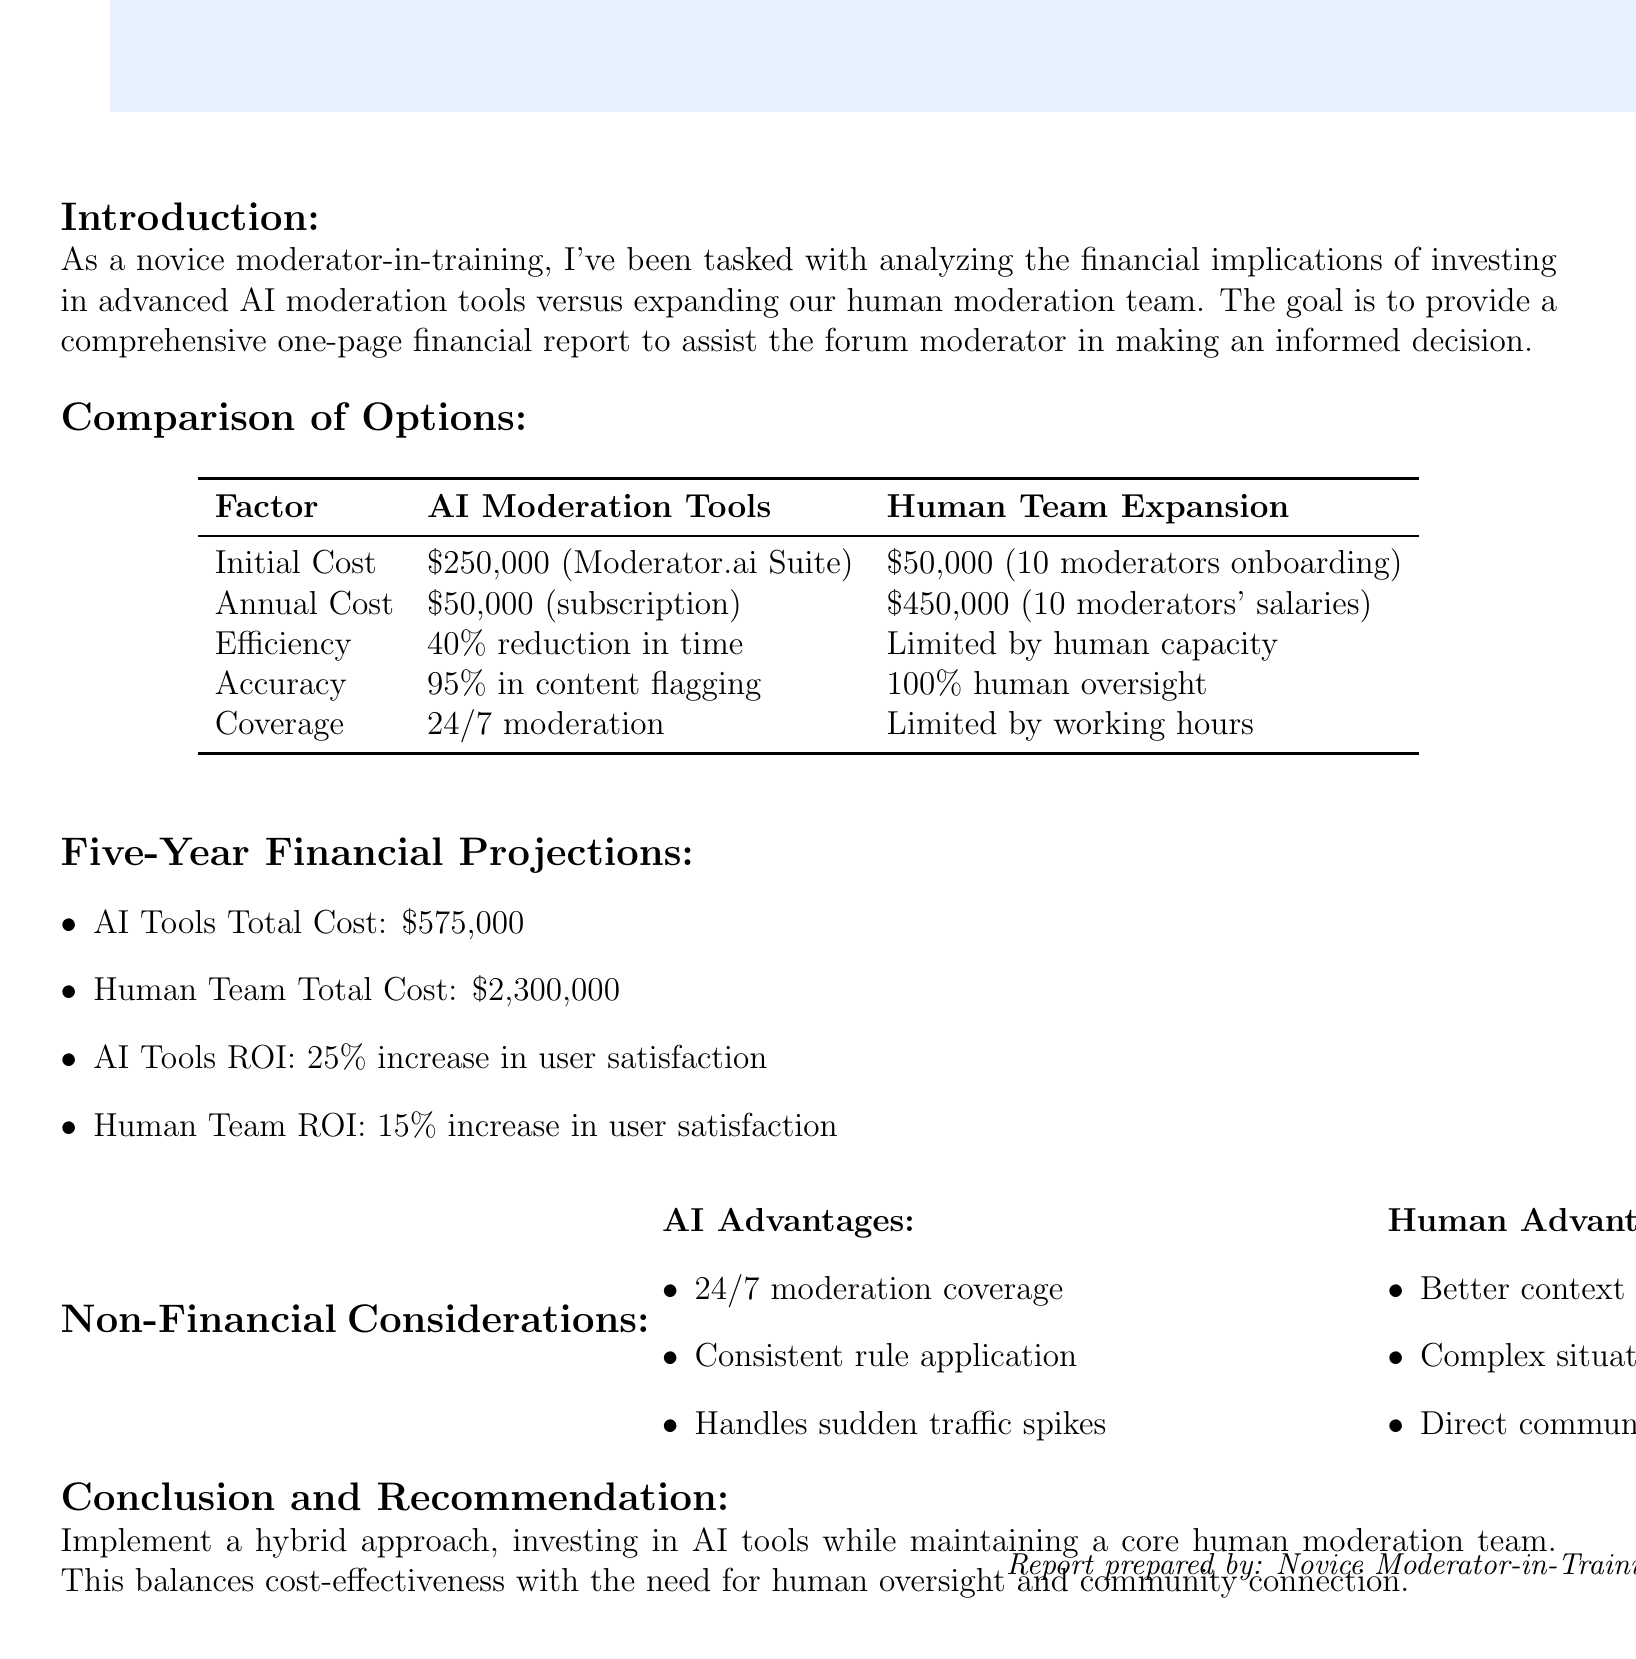What is the initial investment for AI moderation tools? The initial investment for AI moderation tools is specified in the document as $250,000 for the Moderator.ai Enterprise Suite.
Answer: $250,000 What is the annual salary per human moderator? The annual salary per human moderator is stated as $45,000 in the document.
Answer: $45,000 How much is the annual subscription for AI moderation tools? The document mentions the annual subscription for AI moderation tools is $50,000.
Answer: $50,000 What is the total cost of expanding the human moderation team over five years? The total cost for expanding the human moderation team over five years is provided in the document as $2,300,000.
Answer: $2,300,000 What is the projected ROI increase in user satisfaction for AI tools? The projected ROI increase in user satisfaction for AI tools according to the report is 25%.
Answer: 25% Which option offers 24/7 moderation coverage? The document highlights that AI moderation tools provide 24/7 moderation coverage, making them a key advantage.
Answer: AI Moderation Tools What is the main recommendation in the conclusion? The conclusion recommends implementing a hybrid approach, which balances both AI tools and human moderators.
Answer: Hybrid approach How many full-time moderators are to be hired if the team is expanded? The document states that the expansion involves hiring 10 full-time moderators.
Answer: 10 What is the efficiency gain estimated for AI moderation tools? According to the document, the estimated efficiency gain for AI moderation tools is a 40% reduction in moderation time.
Answer: 40% What advantage do human moderators have over AI tools? The document notes that human moderators have better understanding of context and nuance as an advantage.
Answer: Better understanding of context and nuance 